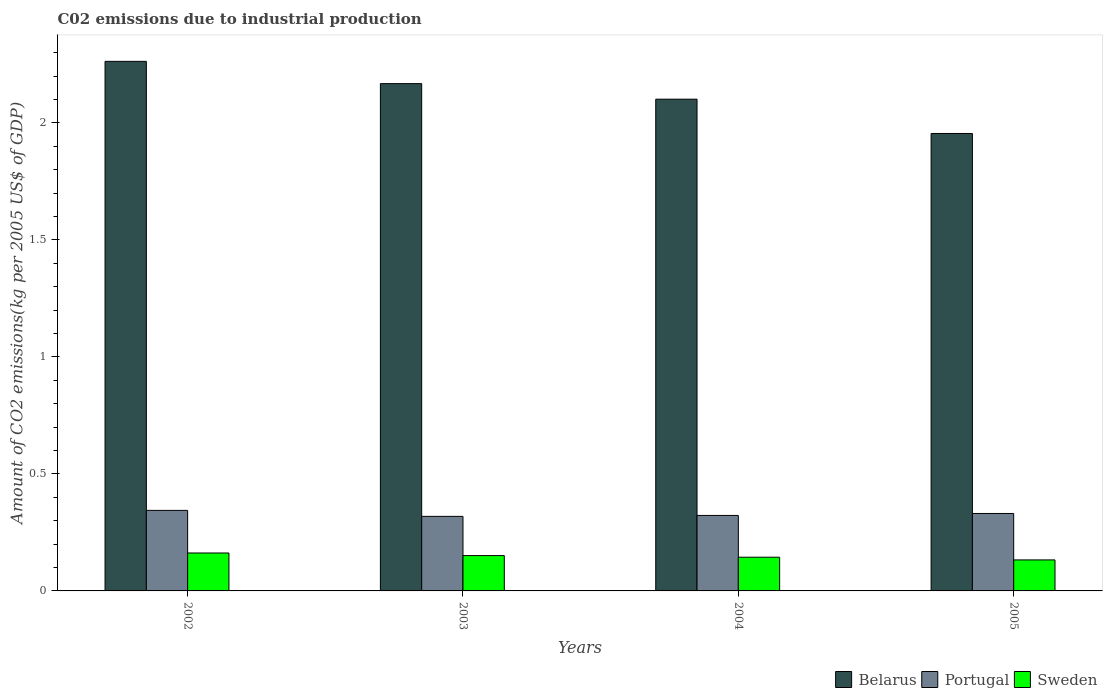How many different coloured bars are there?
Keep it short and to the point. 3. How many groups of bars are there?
Give a very brief answer. 4. Are the number of bars per tick equal to the number of legend labels?
Give a very brief answer. Yes. How many bars are there on the 4th tick from the right?
Offer a terse response. 3. What is the amount of CO2 emitted due to industrial production in Portugal in 2005?
Provide a short and direct response. 0.33. Across all years, what is the maximum amount of CO2 emitted due to industrial production in Portugal?
Give a very brief answer. 0.34. Across all years, what is the minimum amount of CO2 emitted due to industrial production in Belarus?
Your answer should be compact. 1.96. In which year was the amount of CO2 emitted due to industrial production in Portugal minimum?
Give a very brief answer. 2003. What is the total amount of CO2 emitted due to industrial production in Belarus in the graph?
Keep it short and to the point. 8.49. What is the difference between the amount of CO2 emitted due to industrial production in Portugal in 2002 and that in 2005?
Ensure brevity in your answer.  0.01. What is the difference between the amount of CO2 emitted due to industrial production in Belarus in 2005 and the amount of CO2 emitted due to industrial production in Portugal in 2002?
Offer a very short reply. 1.61. What is the average amount of CO2 emitted due to industrial production in Sweden per year?
Your answer should be compact. 0.15. In the year 2003, what is the difference between the amount of CO2 emitted due to industrial production in Belarus and amount of CO2 emitted due to industrial production in Sweden?
Make the answer very short. 2.02. What is the ratio of the amount of CO2 emitted due to industrial production in Belarus in 2002 to that in 2003?
Ensure brevity in your answer.  1.04. Is the amount of CO2 emitted due to industrial production in Sweden in 2004 less than that in 2005?
Your response must be concise. No. Is the difference between the amount of CO2 emitted due to industrial production in Belarus in 2004 and 2005 greater than the difference between the amount of CO2 emitted due to industrial production in Sweden in 2004 and 2005?
Offer a terse response. Yes. What is the difference between the highest and the second highest amount of CO2 emitted due to industrial production in Portugal?
Your answer should be very brief. 0.01. What is the difference between the highest and the lowest amount of CO2 emitted due to industrial production in Portugal?
Make the answer very short. 0.03. What does the 1st bar from the left in 2004 represents?
Provide a succinct answer. Belarus. What does the 3rd bar from the right in 2002 represents?
Provide a succinct answer. Belarus. How many bars are there?
Your response must be concise. 12. How many years are there in the graph?
Your response must be concise. 4. Does the graph contain any zero values?
Your answer should be compact. No. Does the graph contain grids?
Provide a succinct answer. No. Where does the legend appear in the graph?
Give a very brief answer. Bottom right. How are the legend labels stacked?
Provide a short and direct response. Horizontal. What is the title of the graph?
Ensure brevity in your answer.  C02 emissions due to industrial production. What is the label or title of the Y-axis?
Give a very brief answer. Amount of CO2 emissions(kg per 2005 US$ of GDP). What is the Amount of CO2 emissions(kg per 2005 US$ of GDP) in Belarus in 2002?
Your answer should be very brief. 2.26. What is the Amount of CO2 emissions(kg per 2005 US$ of GDP) of Portugal in 2002?
Your response must be concise. 0.34. What is the Amount of CO2 emissions(kg per 2005 US$ of GDP) in Sweden in 2002?
Offer a very short reply. 0.16. What is the Amount of CO2 emissions(kg per 2005 US$ of GDP) of Belarus in 2003?
Provide a succinct answer. 2.17. What is the Amount of CO2 emissions(kg per 2005 US$ of GDP) of Portugal in 2003?
Offer a terse response. 0.32. What is the Amount of CO2 emissions(kg per 2005 US$ of GDP) in Sweden in 2003?
Offer a very short reply. 0.15. What is the Amount of CO2 emissions(kg per 2005 US$ of GDP) of Belarus in 2004?
Your answer should be compact. 2.1. What is the Amount of CO2 emissions(kg per 2005 US$ of GDP) in Portugal in 2004?
Your answer should be very brief. 0.32. What is the Amount of CO2 emissions(kg per 2005 US$ of GDP) of Sweden in 2004?
Offer a very short reply. 0.14. What is the Amount of CO2 emissions(kg per 2005 US$ of GDP) in Belarus in 2005?
Your answer should be compact. 1.96. What is the Amount of CO2 emissions(kg per 2005 US$ of GDP) in Portugal in 2005?
Offer a very short reply. 0.33. What is the Amount of CO2 emissions(kg per 2005 US$ of GDP) of Sweden in 2005?
Offer a very short reply. 0.13. Across all years, what is the maximum Amount of CO2 emissions(kg per 2005 US$ of GDP) in Belarus?
Make the answer very short. 2.26. Across all years, what is the maximum Amount of CO2 emissions(kg per 2005 US$ of GDP) in Portugal?
Your answer should be compact. 0.34. Across all years, what is the maximum Amount of CO2 emissions(kg per 2005 US$ of GDP) of Sweden?
Make the answer very short. 0.16. Across all years, what is the minimum Amount of CO2 emissions(kg per 2005 US$ of GDP) of Belarus?
Your response must be concise. 1.96. Across all years, what is the minimum Amount of CO2 emissions(kg per 2005 US$ of GDP) in Portugal?
Your answer should be very brief. 0.32. Across all years, what is the minimum Amount of CO2 emissions(kg per 2005 US$ of GDP) in Sweden?
Make the answer very short. 0.13. What is the total Amount of CO2 emissions(kg per 2005 US$ of GDP) of Belarus in the graph?
Provide a short and direct response. 8.49. What is the total Amount of CO2 emissions(kg per 2005 US$ of GDP) in Portugal in the graph?
Keep it short and to the point. 1.32. What is the total Amount of CO2 emissions(kg per 2005 US$ of GDP) in Sweden in the graph?
Make the answer very short. 0.59. What is the difference between the Amount of CO2 emissions(kg per 2005 US$ of GDP) of Belarus in 2002 and that in 2003?
Your answer should be very brief. 0.1. What is the difference between the Amount of CO2 emissions(kg per 2005 US$ of GDP) of Portugal in 2002 and that in 2003?
Give a very brief answer. 0.03. What is the difference between the Amount of CO2 emissions(kg per 2005 US$ of GDP) in Sweden in 2002 and that in 2003?
Provide a short and direct response. 0.01. What is the difference between the Amount of CO2 emissions(kg per 2005 US$ of GDP) of Belarus in 2002 and that in 2004?
Ensure brevity in your answer.  0.16. What is the difference between the Amount of CO2 emissions(kg per 2005 US$ of GDP) in Portugal in 2002 and that in 2004?
Give a very brief answer. 0.02. What is the difference between the Amount of CO2 emissions(kg per 2005 US$ of GDP) of Sweden in 2002 and that in 2004?
Offer a terse response. 0.02. What is the difference between the Amount of CO2 emissions(kg per 2005 US$ of GDP) of Belarus in 2002 and that in 2005?
Your answer should be compact. 0.31. What is the difference between the Amount of CO2 emissions(kg per 2005 US$ of GDP) of Portugal in 2002 and that in 2005?
Make the answer very short. 0.01. What is the difference between the Amount of CO2 emissions(kg per 2005 US$ of GDP) in Sweden in 2002 and that in 2005?
Provide a succinct answer. 0.03. What is the difference between the Amount of CO2 emissions(kg per 2005 US$ of GDP) of Belarus in 2003 and that in 2004?
Your answer should be very brief. 0.07. What is the difference between the Amount of CO2 emissions(kg per 2005 US$ of GDP) in Portugal in 2003 and that in 2004?
Provide a short and direct response. -0. What is the difference between the Amount of CO2 emissions(kg per 2005 US$ of GDP) in Sweden in 2003 and that in 2004?
Make the answer very short. 0.01. What is the difference between the Amount of CO2 emissions(kg per 2005 US$ of GDP) of Belarus in 2003 and that in 2005?
Offer a very short reply. 0.21. What is the difference between the Amount of CO2 emissions(kg per 2005 US$ of GDP) of Portugal in 2003 and that in 2005?
Provide a short and direct response. -0.01. What is the difference between the Amount of CO2 emissions(kg per 2005 US$ of GDP) of Sweden in 2003 and that in 2005?
Offer a terse response. 0.02. What is the difference between the Amount of CO2 emissions(kg per 2005 US$ of GDP) in Belarus in 2004 and that in 2005?
Your answer should be very brief. 0.15. What is the difference between the Amount of CO2 emissions(kg per 2005 US$ of GDP) in Portugal in 2004 and that in 2005?
Provide a succinct answer. -0.01. What is the difference between the Amount of CO2 emissions(kg per 2005 US$ of GDP) of Sweden in 2004 and that in 2005?
Your answer should be compact. 0.01. What is the difference between the Amount of CO2 emissions(kg per 2005 US$ of GDP) in Belarus in 2002 and the Amount of CO2 emissions(kg per 2005 US$ of GDP) in Portugal in 2003?
Make the answer very short. 1.94. What is the difference between the Amount of CO2 emissions(kg per 2005 US$ of GDP) of Belarus in 2002 and the Amount of CO2 emissions(kg per 2005 US$ of GDP) of Sweden in 2003?
Ensure brevity in your answer.  2.11. What is the difference between the Amount of CO2 emissions(kg per 2005 US$ of GDP) in Portugal in 2002 and the Amount of CO2 emissions(kg per 2005 US$ of GDP) in Sweden in 2003?
Offer a terse response. 0.19. What is the difference between the Amount of CO2 emissions(kg per 2005 US$ of GDP) in Belarus in 2002 and the Amount of CO2 emissions(kg per 2005 US$ of GDP) in Portugal in 2004?
Your response must be concise. 1.94. What is the difference between the Amount of CO2 emissions(kg per 2005 US$ of GDP) in Belarus in 2002 and the Amount of CO2 emissions(kg per 2005 US$ of GDP) in Sweden in 2004?
Make the answer very short. 2.12. What is the difference between the Amount of CO2 emissions(kg per 2005 US$ of GDP) of Portugal in 2002 and the Amount of CO2 emissions(kg per 2005 US$ of GDP) of Sweden in 2004?
Provide a short and direct response. 0.2. What is the difference between the Amount of CO2 emissions(kg per 2005 US$ of GDP) in Belarus in 2002 and the Amount of CO2 emissions(kg per 2005 US$ of GDP) in Portugal in 2005?
Your response must be concise. 1.93. What is the difference between the Amount of CO2 emissions(kg per 2005 US$ of GDP) of Belarus in 2002 and the Amount of CO2 emissions(kg per 2005 US$ of GDP) of Sweden in 2005?
Your response must be concise. 2.13. What is the difference between the Amount of CO2 emissions(kg per 2005 US$ of GDP) of Portugal in 2002 and the Amount of CO2 emissions(kg per 2005 US$ of GDP) of Sweden in 2005?
Offer a very short reply. 0.21. What is the difference between the Amount of CO2 emissions(kg per 2005 US$ of GDP) of Belarus in 2003 and the Amount of CO2 emissions(kg per 2005 US$ of GDP) of Portugal in 2004?
Provide a short and direct response. 1.85. What is the difference between the Amount of CO2 emissions(kg per 2005 US$ of GDP) in Belarus in 2003 and the Amount of CO2 emissions(kg per 2005 US$ of GDP) in Sweden in 2004?
Your answer should be compact. 2.02. What is the difference between the Amount of CO2 emissions(kg per 2005 US$ of GDP) in Portugal in 2003 and the Amount of CO2 emissions(kg per 2005 US$ of GDP) in Sweden in 2004?
Your answer should be compact. 0.17. What is the difference between the Amount of CO2 emissions(kg per 2005 US$ of GDP) of Belarus in 2003 and the Amount of CO2 emissions(kg per 2005 US$ of GDP) of Portugal in 2005?
Provide a short and direct response. 1.84. What is the difference between the Amount of CO2 emissions(kg per 2005 US$ of GDP) of Belarus in 2003 and the Amount of CO2 emissions(kg per 2005 US$ of GDP) of Sweden in 2005?
Provide a succinct answer. 2.04. What is the difference between the Amount of CO2 emissions(kg per 2005 US$ of GDP) in Portugal in 2003 and the Amount of CO2 emissions(kg per 2005 US$ of GDP) in Sweden in 2005?
Your answer should be compact. 0.19. What is the difference between the Amount of CO2 emissions(kg per 2005 US$ of GDP) of Belarus in 2004 and the Amount of CO2 emissions(kg per 2005 US$ of GDP) of Portugal in 2005?
Ensure brevity in your answer.  1.77. What is the difference between the Amount of CO2 emissions(kg per 2005 US$ of GDP) in Belarus in 2004 and the Amount of CO2 emissions(kg per 2005 US$ of GDP) in Sweden in 2005?
Offer a very short reply. 1.97. What is the difference between the Amount of CO2 emissions(kg per 2005 US$ of GDP) of Portugal in 2004 and the Amount of CO2 emissions(kg per 2005 US$ of GDP) of Sweden in 2005?
Keep it short and to the point. 0.19. What is the average Amount of CO2 emissions(kg per 2005 US$ of GDP) in Belarus per year?
Provide a short and direct response. 2.12. What is the average Amount of CO2 emissions(kg per 2005 US$ of GDP) of Portugal per year?
Give a very brief answer. 0.33. What is the average Amount of CO2 emissions(kg per 2005 US$ of GDP) of Sweden per year?
Your answer should be compact. 0.15. In the year 2002, what is the difference between the Amount of CO2 emissions(kg per 2005 US$ of GDP) of Belarus and Amount of CO2 emissions(kg per 2005 US$ of GDP) of Portugal?
Your answer should be very brief. 1.92. In the year 2002, what is the difference between the Amount of CO2 emissions(kg per 2005 US$ of GDP) in Belarus and Amount of CO2 emissions(kg per 2005 US$ of GDP) in Sweden?
Provide a succinct answer. 2.1. In the year 2002, what is the difference between the Amount of CO2 emissions(kg per 2005 US$ of GDP) in Portugal and Amount of CO2 emissions(kg per 2005 US$ of GDP) in Sweden?
Keep it short and to the point. 0.18. In the year 2003, what is the difference between the Amount of CO2 emissions(kg per 2005 US$ of GDP) in Belarus and Amount of CO2 emissions(kg per 2005 US$ of GDP) in Portugal?
Provide a succinct answer. 1.85. In the year 2003, what is the difference between the Amount of CO2 emissions(kg per 2005 US$ of GDP) in Belarus and Amount of CO2 emissions(kg per 2005 US$ of GDP) in Sweden?
Offer a terse response. 2.02. In the year 2003, what is the difference between the Amount of CO2 emissions(kg per 2005 US$ of GDP) in Portugal and Amount of CO2 emissions(kg per 2005 US$ of GDP) in Sweden?
Provide a short and direct response. 0.17. In the year 2004, what is the difference between the Amount of CO2 emissions(kg per 2005 US$ of GDP) in Belarus and Amount of CO2 emissions(kg per 2005 US$ of GDP) in Portugal?
Ensure brevity in your answer.  1.78. In the year 2004, what is the difference between the Amount of CO2 emissions(kg per 2005 US$ of GDP) of Belarus and Amount of CO2 emissions(kg per 2005 US$ of GDP) of Sweden?
Your response must be concise. 1.96. In the year 2004, what is the difference between the Amount of CO2 emissions(kg per 2005 US$ of GDP) of Portugal and Amount of CO2 emissions(kg per 2005 US$ of GDP) of Sweden?
Offer a terse response. 0.18. In the year 2005, what is the difference between the Amount of CO2 emissions(kg per 2005 US$ of GDP) of Belarus and Amount of CO2 emissions(kg per 2005 US$ of GDP) of Portugal?
Provide a short and direct response. 1.62. In the year 2005, what is the difference between the Amount of CO2 emissions(kg per 2005 US$ of GDP) of Belarus and Amount of CO2 emissions(kg per 2005 US$ of GDP) of Sweden?
Offer a terse response. 1.82. In the year 2005, what is the difference between the Amount of CO2 emissions(kg per 2005 US$ of GDP) in Portugal and Amount of CO2 emissions(kg per 2005 US$ of GDP) in Sweden?
Provide a succinct answer. 0.2. What is the ratio of the Amount of CO2 emissions(kg per 2005 US$ of GDP) of Belarus in 2002 to that in 2003?
Offer a very short reply. 1.04. What is the ratio of the Amount of CO2 emissions(kg per 2005 US$ of GDP) of Portugal in 2002 to that in 2003?
Offer a very short reply. 1.08. What is the ratio of the Amount of CO2 emissions(kg per 2005 US$ of GDP) in Sweden in 2002 to that in 2003?
Provide a succinct answer. 1.07. What is the ratio of the Amount of CO2 emissions(kg per 2005 US$ of GDP) of Portugal in 2002 to that in 2004?
Offer a terse response. 1.07. What is the ratio of the Amount of CO2 emissions(kg per 2005 US$ of GDP) of Sweden in 2002 to that in 2004?
Provide a short and direct response. 1.12. What is the ratio of the Amount of CO2 emissions(kg per 2005 US$ of GDP) of Belarus in 2002 to that in 2005?
Your answer should be very brief. 1.16. What is the ratio of the Amount of CO2 emissions(kg per 2005 US$ of GDP) of Portugal in 2002 to that in 2005?
Keep it short and to the point. 1.04. What is the ratio of the Amount of CO2 emissions(kg per 2005 US$ of GDP) of Sweden in 2002 to that in 2005?
Make the answer very short. 1.22. What is the ratio of the Amount of CO2 emissions(kg per 2005 US$ of GDP) of Belarus in 2003 to that in 2004?
Ensure brevity in your answer.  1.03. What is the ratio of the Amount of CO2 emissions(kg per 2005 US$ of GDP) in Portugal in 2003 to that in 2004?
Provide a succinct answer. 0.99. What is the ratio of the Amount of CO2 emissions(kg per 2005 US$ of GDP) of Sweden in 2003 to that in 2004?
Your answer should be very brief. 1.05. What is the ratio of the Amount of CO2 emissions(kg per 2005 US$ of GDP) of Belarus in 2003 to that in 2005?
Your response must be concise. 1.11. What is the ratio of the Amount of CO2 emissions(kg per 2005 US$ of GDP) in Portugal in 2003 to that in 2005?
Your answer should be very brief. 0.96. What is the ratio of the Amount of CO2 emissions(kg per 2005 US$ of GDP) in Sweden in 2003 to that in 2005?
Make the answer very short. 1.14. What is the ratio of the Amount of CO2 emissions(kg per 2005 US$ of GDP) of Belarus in 2004 to that in 2005?
Your answer should be very brief. 1.07. What is the ratio of the Amount of CO2 emissions(kg per 2005 US$ of GDP) in Portugal in 2004 to that in 2005?
Provide a succinct answer. 0.97. What is the ratio of the Amount of CO2 emissions(kg per 2005 US$ of GDP) of Sweden in 2004 to that in 2005?
Give a very brief answer. 1.09. What is the difference between the highest and the second highest Amount of CO2 emissions(kg per 2005 US$ of GDP) in Belarus?
Provide a short and direct response. 0.1. What is the difference between the highest and the second highest Amount of CO2 emissions(kg per 2005 US$ of GDP) of Portugal?
Keep it short and to the point. 0.01. What is the difference between the highest and the second highest Amount of CO2 emissions(kg per 2005 US$ of GDP) of Sweden?
Make the answer very short. 0.01. What is the difference between the highest and the lowest Amount of CO2 emissions(kg per 2005 US$ of GDP) of Belarus?
Keep it short and to the point. 0.31. What is the difference between the highest and the lowest Amount of CO2 emissions(kg per 2005 US$ of GDP) of Portugal?
Make the answer very short. 0.03. What is the difference between the highest and the lowest Amount of CO2 emissions(kg per 2005 US$ of GDP) in Sweden?
Provide a succinct answer. 0.03. 